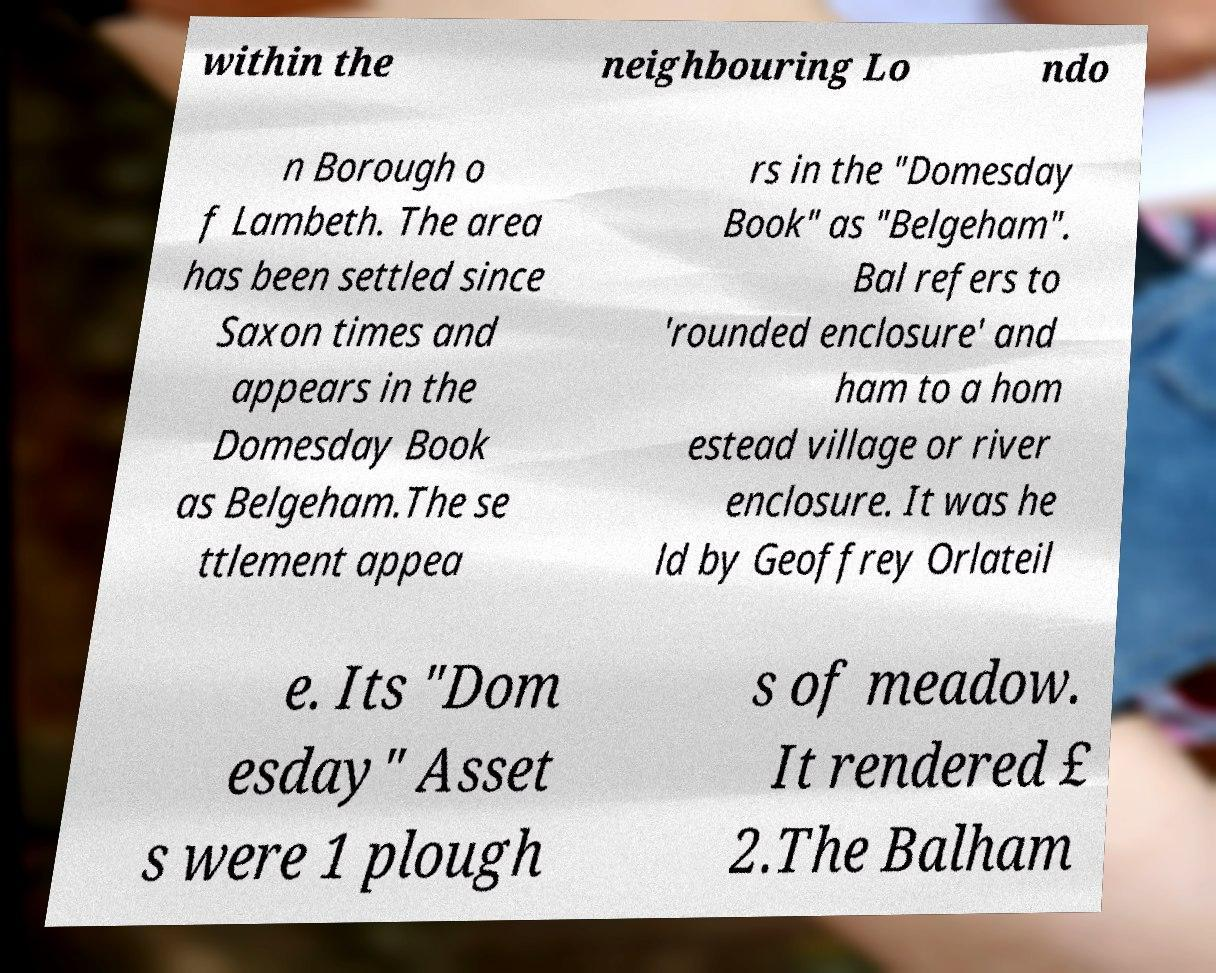Could you assist in decoding the text presented in this image and type it out clearly? within the neighbouring Lo ndo n Borough o f Lambeth. The area has been settled since Saxon times and appears in the Domesday Book as Belgeham.The se ttlement appea rs in the "Domesday Book" as "Belgeham". Bal refers to 'rounded enclosure' and ham to a hom estead village or river enclosure. It was he ld by Geoffrey Orlateil e. Its "Dom esday" Asset s were 1 plough s of meadow. It rendered £ 2.The Balham 